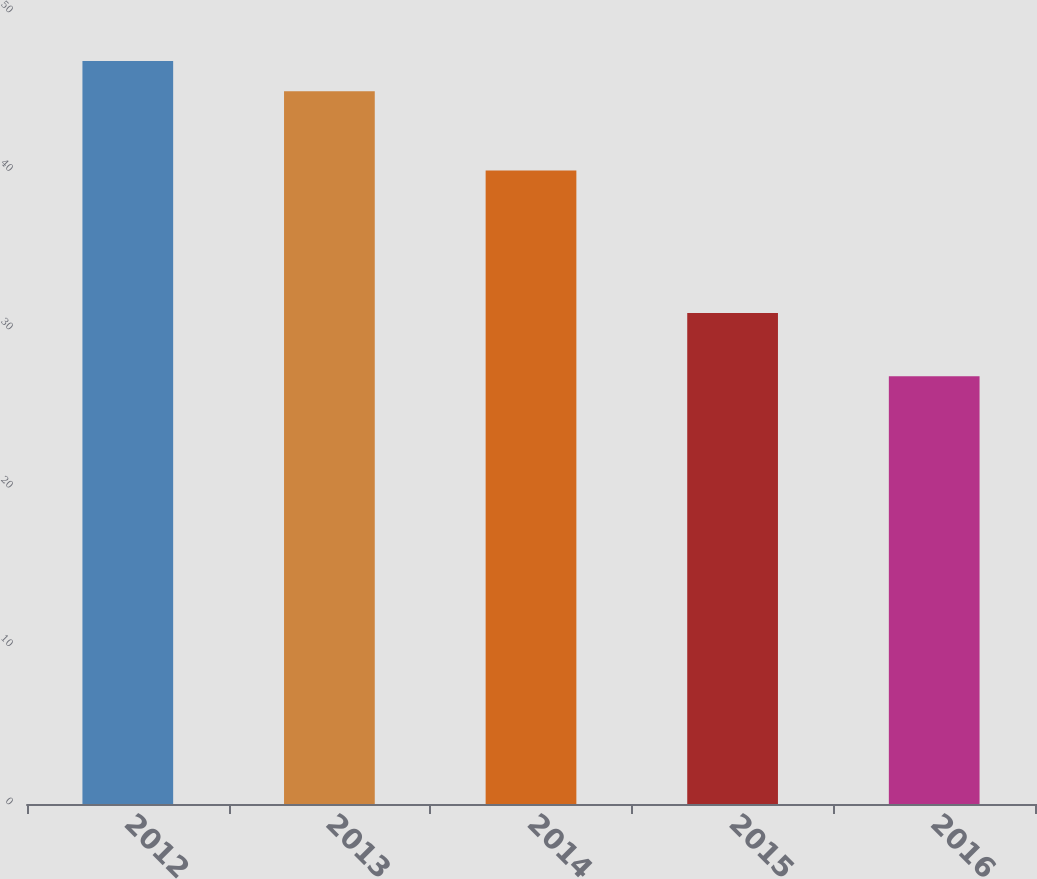<chart> <loc_0><loc_0><loc_500><loc_500><bar_chart><fcel>2012<fcel>2013<fcel>2014<fcel>2015<fcel>2016<nl><fcel>46.9<fcel>45<fcel>40<fcel>31<fcel>27<nl></chart> 